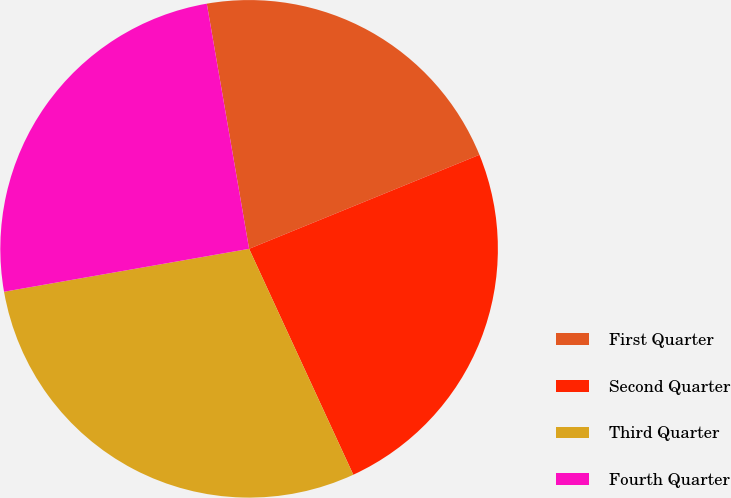Convert chart. <chart><loc_0><loc_0><loc_500><loc_500><pie_chart><fcel>First Quarter<fcel>Second Quarter<fcel>Third Quarter<fcel>Fourth Quarter<nl><fcel>21.55%<fcel>24.29%<fcel>29.12%<fcel>25.04%<nl></chart> 